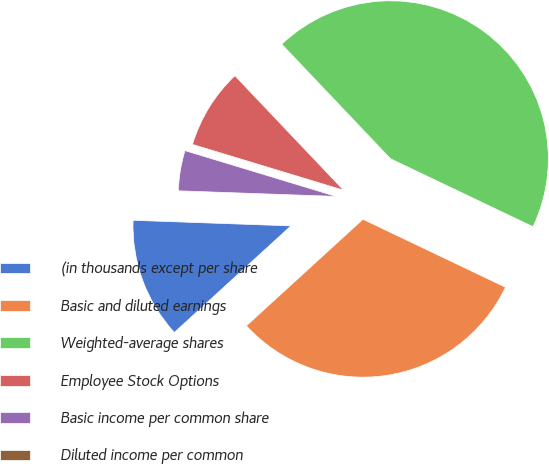<chart> <loc_0><loc_0><loc_500><loc_500><pie_chart><fcel>(in thousands except per share<fcel>Basic and diluted earnings<fcel>Weighted-average shares<fcel>Employee Stock Options<fcel>Basic income per common share<fcel>Diluted income per common<nl><fcel>12.35%<fcel>31.13%<fcel>44.17%<fcel>8.23%<fcel>4.12%<fcel>0.0%<nl></chart> 